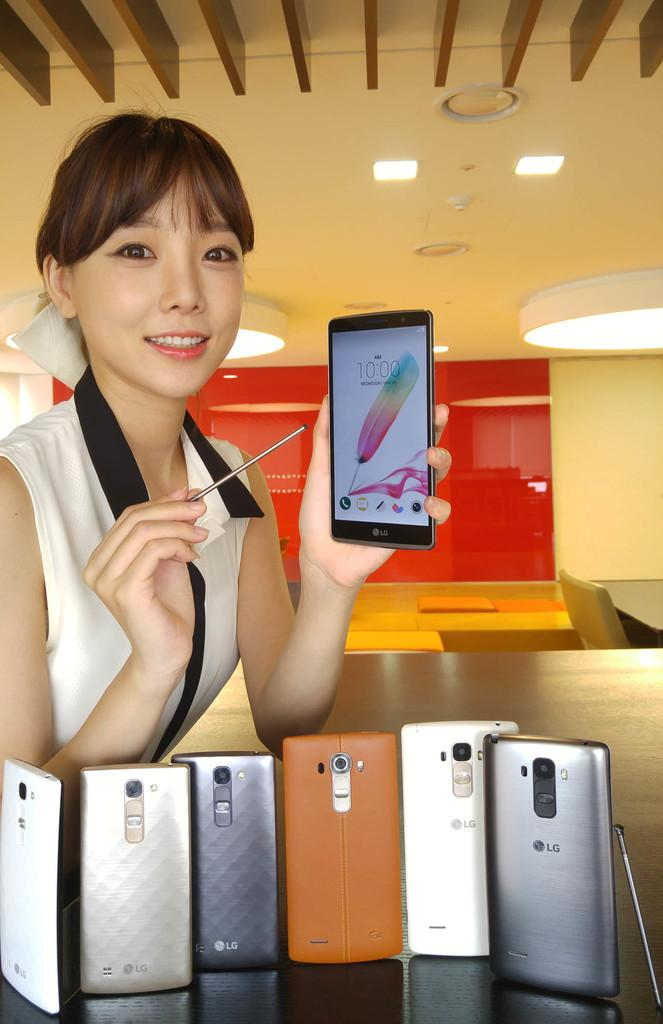What objects are present in the image that are related to communication? There are multiple mobiles in the image. Can you describe the actions of the person in the image? There is a person holding a mobile in the image. What time does the clock in the image show? There is no clock present in the image. How does the steam affect the person holding the mobile in the image? There is no steam present in the image. 